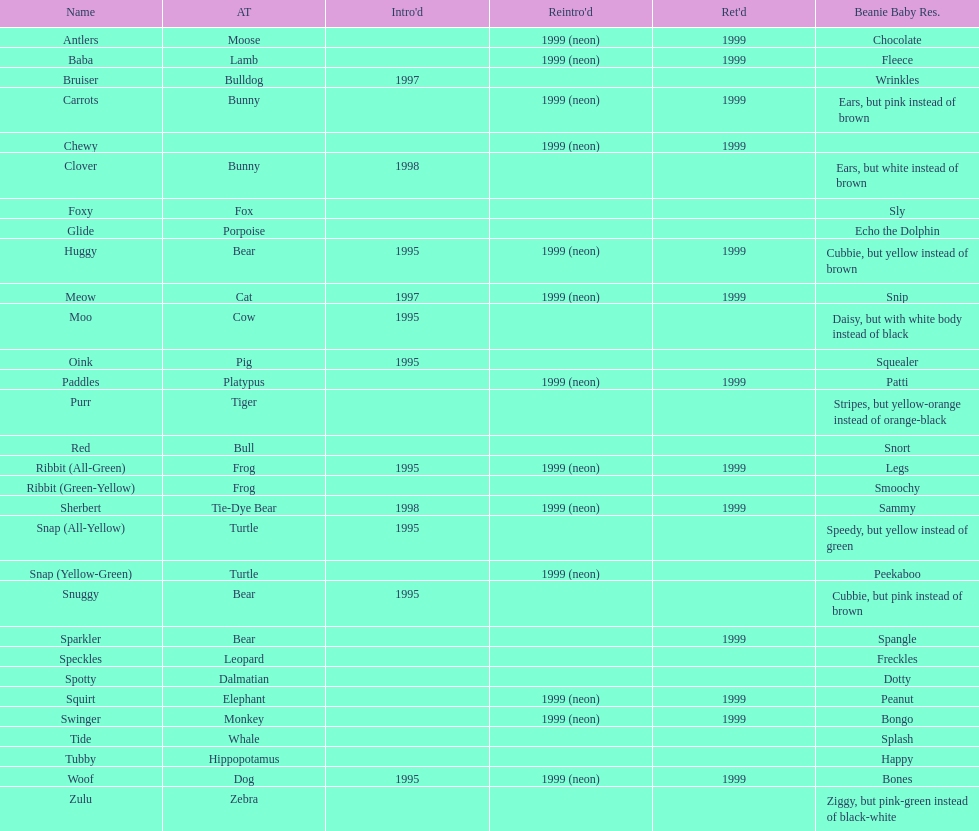How many total pillow pals were both reintroduced and retired in 1999? 12. 